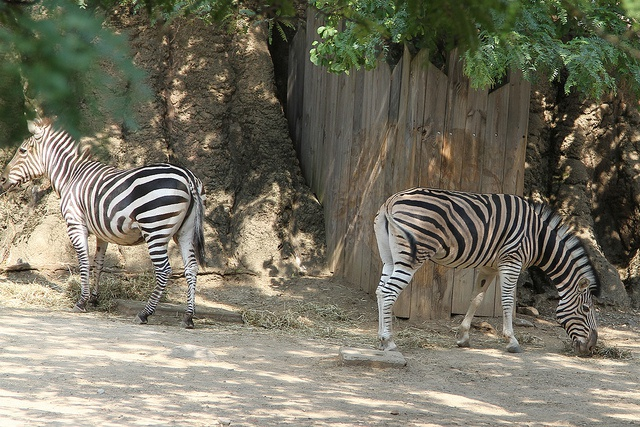Describe the objects in this image and their specific colors. I can see zebra in black, darkgray, and gray tones and zebra in black, lightgray, gray, and darkgray tones in this image. 